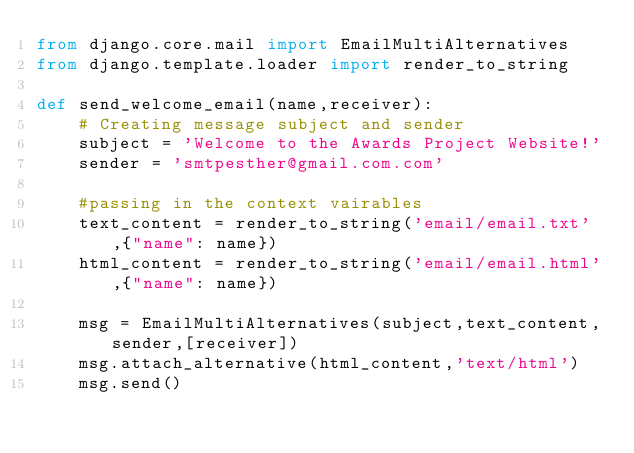<code> <loc_0><loc_0><loc_500><loc_500><_Python_>from django.core.mail import EmailMultiAlternatives
from django.template.loader import render_to_string

def send_welcome_email(name,receiver):
    # Creating message subject and sender
    subject = 'Welcome to the Awards Project Website!'
    sender = 'smtpesther@gmail.com.com'

    #passing in the context vairables
    text_content = render_to_string('email/email.txt',{"name": name})
    html_content = render_to_string('email/email.html',{"name": name})

    msg = EmailMultiAlternatives(subject,text_content,sender,[receiver])
    msg.attach_alternative(html_content,'text/html')
    msg.send()</code> 